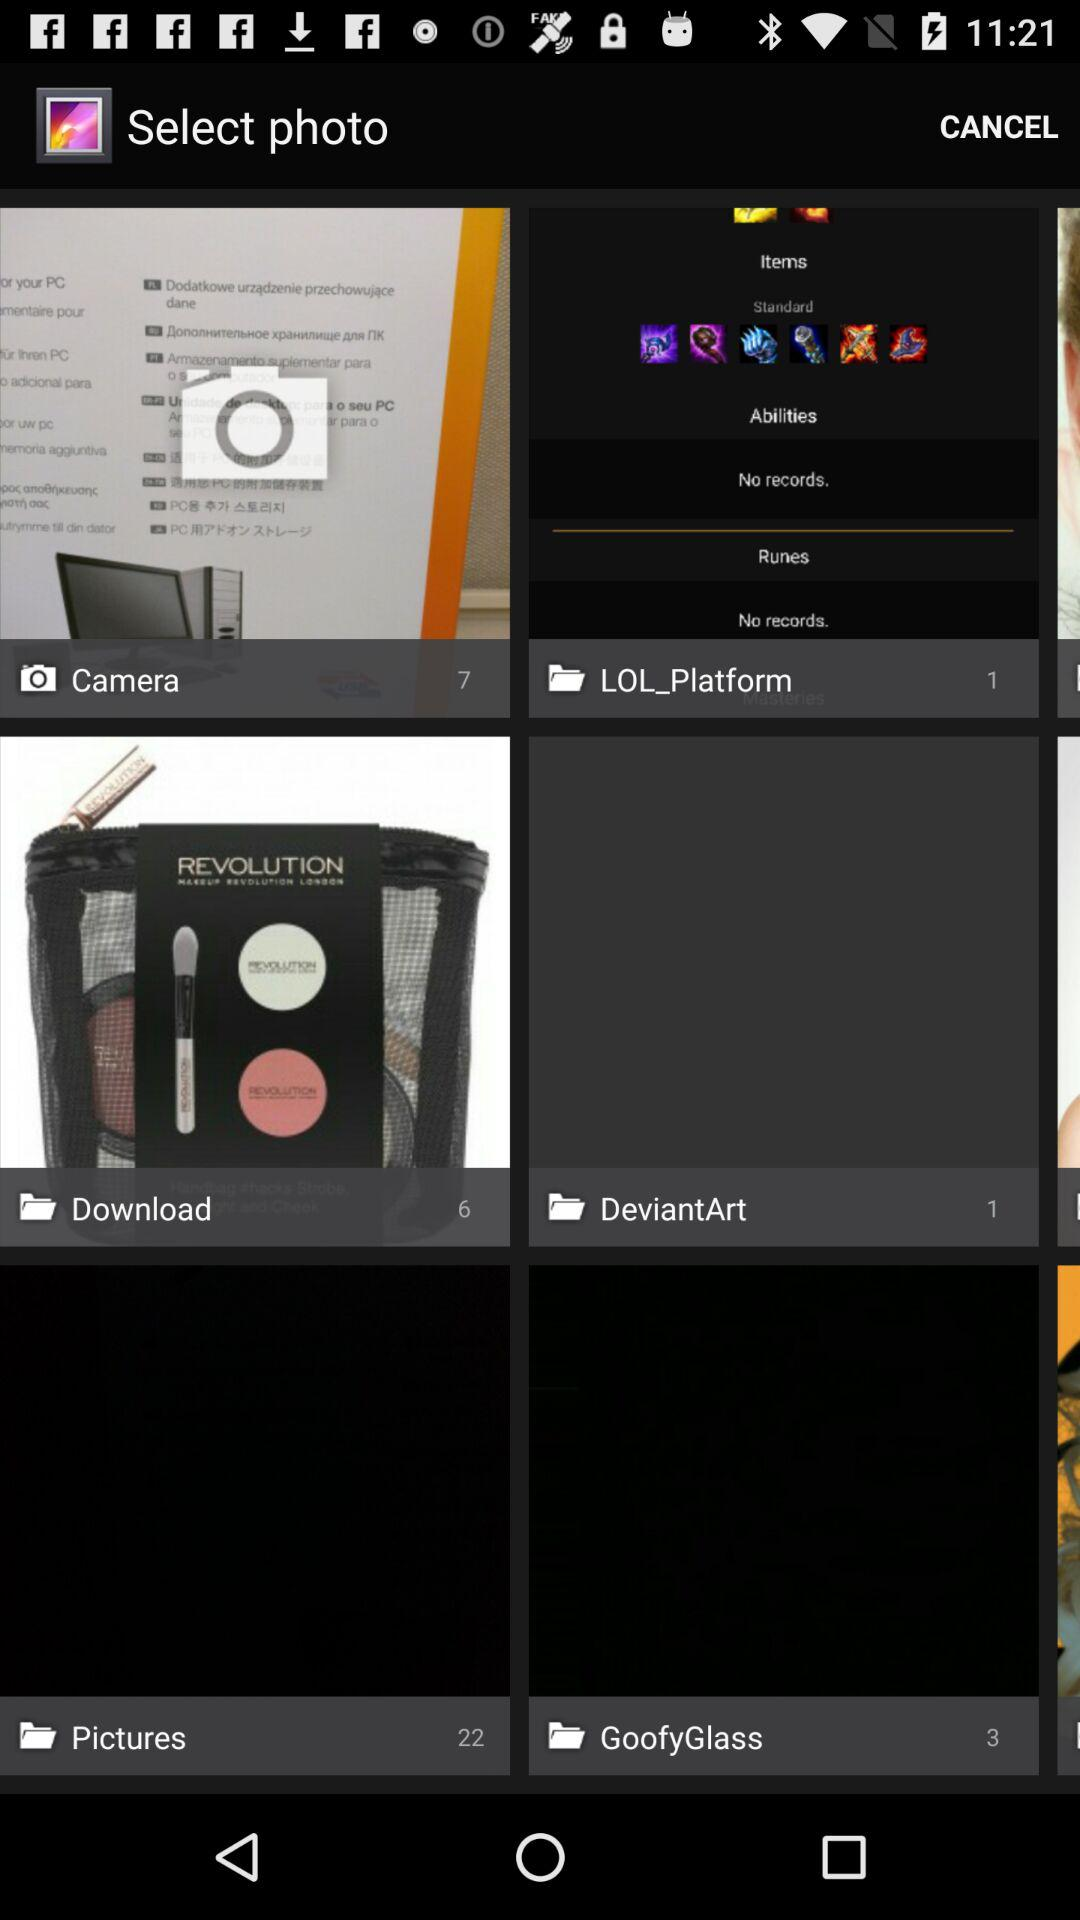Which folder has six images? The folder that has six images is "Download". 